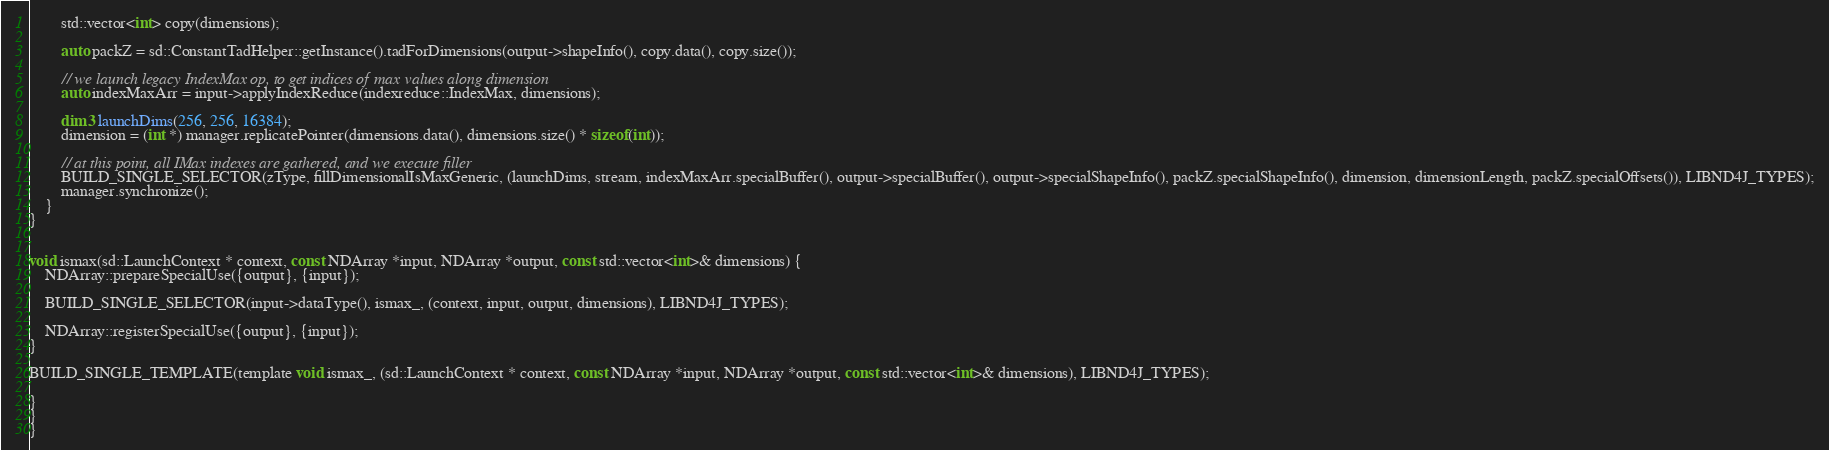<code> <loc_0><loc_0><loc_500><loc_500><_Cuda_>        std::vector<int> copy(dimensions);

        auto packZ = sd::ConstantTadHelper::getInstance().tadForDimensions(output->shapeInfo(), copy.data(), copy.size());

        // we launch legacy IndexMax op, to get indices of max values along dimension
        auto indexMaxArr = input->applyIndexReduce(indexreduce::IndexMax, dimensions);

        dim3 launchDims(256, 256, 16384);
        dimension = (int *) manager.replicatePointer(dimensions.data(), dimensions.size() * sizeof(int));

        // at this point, all IMax indexes are gathered, and we execute filler
        BUILD_SINGLE_SELECTOR(zType, fillDimensionalIsMaxGeneric, (launchDims, stream, indexMaxArr.specialBuffer(), output->specialBuffer(), output->specialShapeInfo(), packZ.specialShapeInfo(), dimension, dimensionLength, packZ.specialOffsets()), LIBND4J_TYPES);
        manager.synchronize();
    }
}


void ismax(sd::LaunchContext * context, const NDArray *input, NDArray *output, const std::vector<int>& dimensions) {
    NDArray::prepareSpecialUse({output}, {input});

    BUILD_SINGLE_SELECTOR(input->dataType(), ismax_, (context, input, output, dimensions), LIBND4J_TYPES);

    NDArray::registerSpecialUse({output}, {input});
}

BUILD_SINGLE_TEMPLATE(template void ismax_, (sd::LaunchContext * context, const NDArray *input, NDArray *output, const std::vector<int>& dimensions), LIBND4J_TYPES);

}
}
}

</code> 